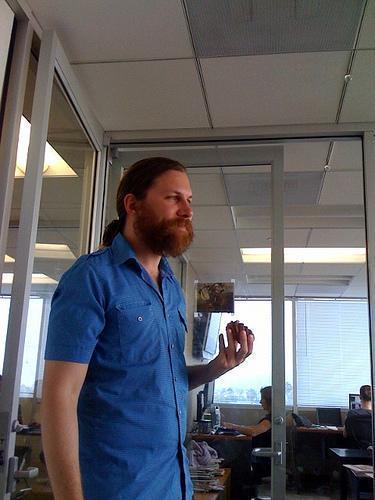What office reprieve does this man avail himself of?
Select the accurate response from the four choices given to answer the question.
Options: Coffee break, airplane building, nap, filing. Coffee break. 